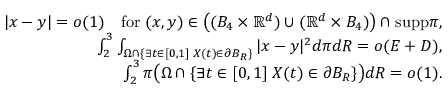<formula> <loc_0><loc_0><loc_500><loc_500>\begin{array} { r } { | x - y | = o ( 1 ) \quad f o r \, ( x , y ) \in \left ( ( B _ { 4 } \times \mathbb { R } ^ { d } ) \cup ( \mathbb { R } ^ { d } \times B _ { 4 } ) \right ) \cap s u p p \pi , } \\ { \int _ { 2 } ^ { 3 } \int _ { \Omega \cap \{ \exists t \in [ 0 , 1 ] \, X ( t ) \in \partial B _ { R } \} } | x - y | ^ { 2 } d \pi d R = o ( E + D ) , } \\ { \int _ { 2 } ^ { 3 } \pi \left ( \Omega \cap \{ \exists t \in [ 0 , 1 ] \, X ( t ) \in \partial B _ { R } \} \right ) d R = o ( 1 ) . } \end{array}</formula> 